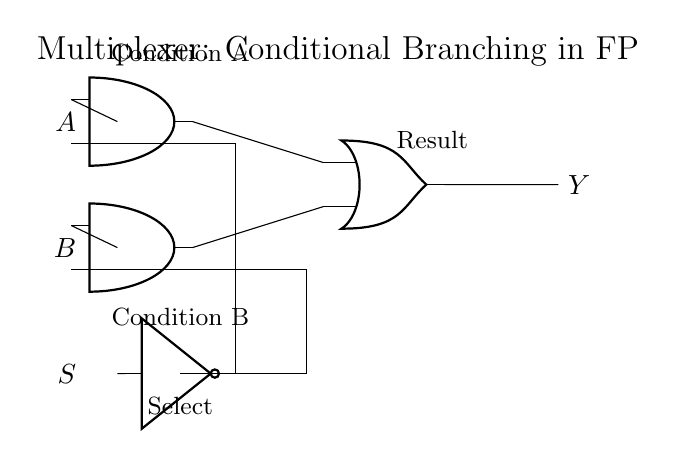What is the output of the multiplexer when the select line S is high? When the select line S is high, the multiplexer allows the input from A to pass to the output Y. This is determined by the connection made to the AND gate linked to S.
Answer: A What conditions must be met for output Y to be high? For output Y to be high, both conditions A must be high when S is high, or condition B must be high when S is low. This can be inferred from the configuration where A and B connect through AND gates to an OR gate.
Answer: Condition A high or Condition B high Which components are used in this multiplexer circuit? The components include AND gates, an OR gate, and a NOT gate. Identifying these is straightforward from the visual representation in the diagram.
Answer: AND gates, OR gate, NOT gate What role does the NOT gate play in the circuit? The NOT gate inverts the select line S, allowing for conditional branching in the logic of this multiplexer. This inversion is crucial for ensuring that when S is low, the B input is considered instead of A.
Answer: Inverts select line How many inputs does the multiplexer have? The multiplexer has two primary inputs (A and B) and one select input (S). When analyzing the inputs from the diagram, these three points can be clearly identified.
Answer: Two inputs What is the purpose of the OR gate in this circuit? The OR gate combines the outputs of the two AND gates. Its purpose is to produce the final output Y when either input A or input B is selected based on the condition of S.
Answer: Combines AND outputs 